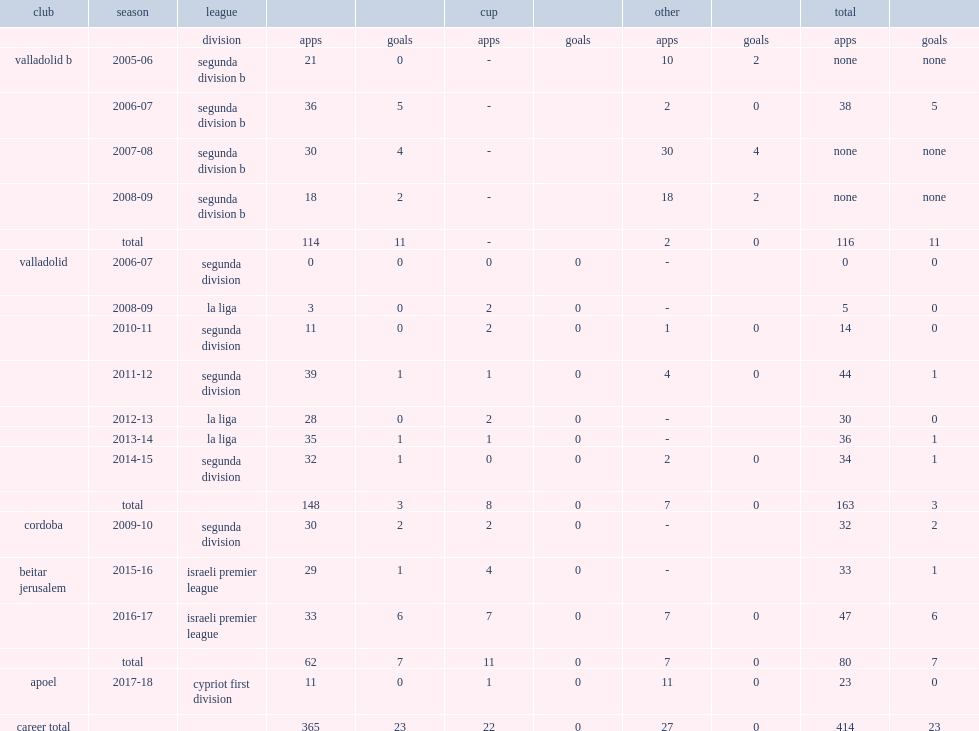How many matches did jesus rueda play for valladolid totally? 163.0. 